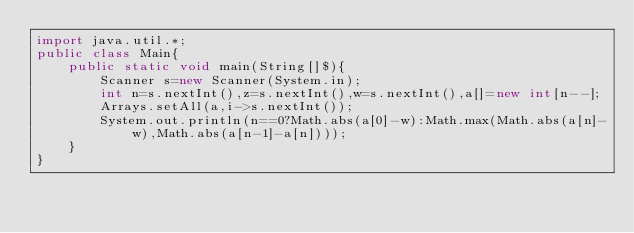Convert code to text. <code><loc_0><loc_0><loc_500><loc_500><_Java_>import java.util.*;
public class Main{
    public static void main(String[]$){
		Scanner s=new Scanner(System.in);
		int n=s.nextInt(),z=s.nextInt(),w=s.nextInt(),a[]=new int[n--];
		Arrays.setAll(a,i->s.nextInt());
		System.out.println(n==0?Math.abs(a[0]-w):Math.max(Math.abs(a[n]-w),Math.abs(a[n-1]-a[n])));
	}
}</code> 